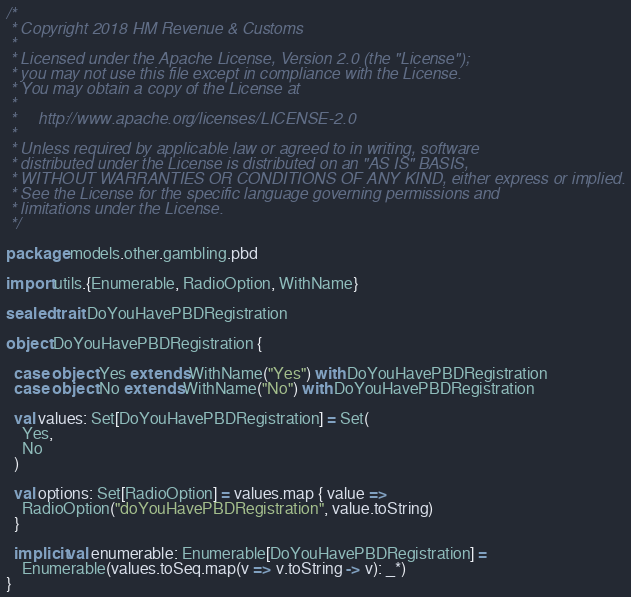Convert code to text. <code><loc_0><loc_0><loc_500><loc_500><_Scala_>/*
 * Copyright 2018 HM Revenue & Customs
 *
 * Licensed under the Apache License, Version 2.0 (the "License");
 * you may not use this file except in compliance with the License.
 * You may obtain a copy of the License at
 *
 *     http://www.apache.org/licenses/LICENSE-2.0
 *
 * Unless required by applicable law or agreed to in writing, software
 * distributed under the License is distributed on an "AS IS" BASIS,
 * WITHOUT WARRANTIES OR CONDITIONS OF ANY KIND, either express or implied.
 * See the License for the specific language governing permissions and
 * limitations under the License.
 */

package models.other.gambling.pbd

import utils.{Enumerable, RadioOption, WithName}

sealed trait DoYouHavePBDRegistration

object DoYouHavePBDRegistration {

  case object Yes extends WithName("Yes") with DoYouHavePBDRegistration
  case object No extends WithName("No") with DoYouHavePBDRegistration

  val values: Set[DoYouHavePBDRegistration] = Set(
    Yes,
    No
  )

  val options: Set[RadioOption] = values.map { value =>
    RadioOption("doYouHavePBDRegistration", value.toString)
  }

  implicit val enumerable: Enumerable[DoYouHavePBDRegistration] =
    Enumerable(values.toSeq.map(v => v.toString -> v): _*)
}
</code> 